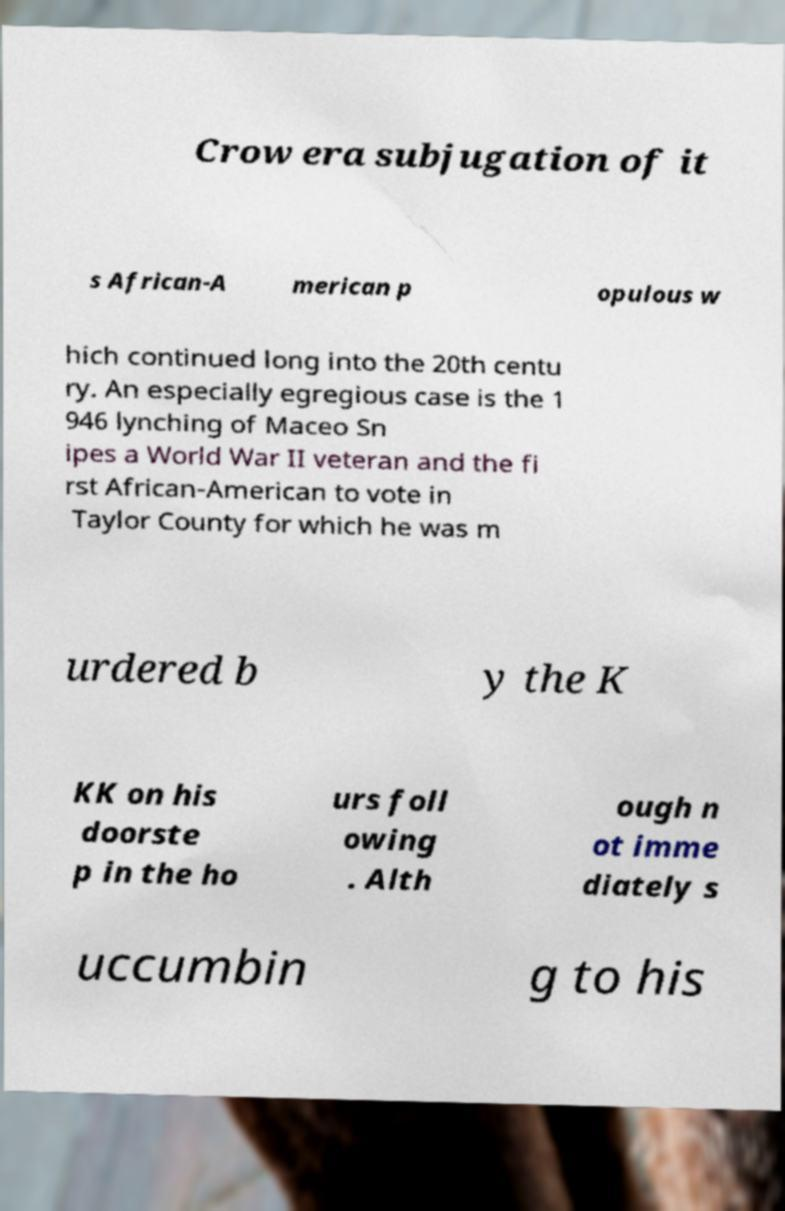Can you read and provide the text displayed in the image?This photo seems to have some interesting text. Can you extract and type it out for me? Crow era subjugation of it s African-A merican p opulous w hich continued long into the 20th centu ry. An especially egregious case is the 1 946 lynching of Maceo Sn ipes a World War II veteran and the fi rst African-American to vote in Taylor County for which he was m urdered b y the K KK on his doorste p in the ho urs foll owing . Alth ough n ot imme diately s uccumbin g to his 